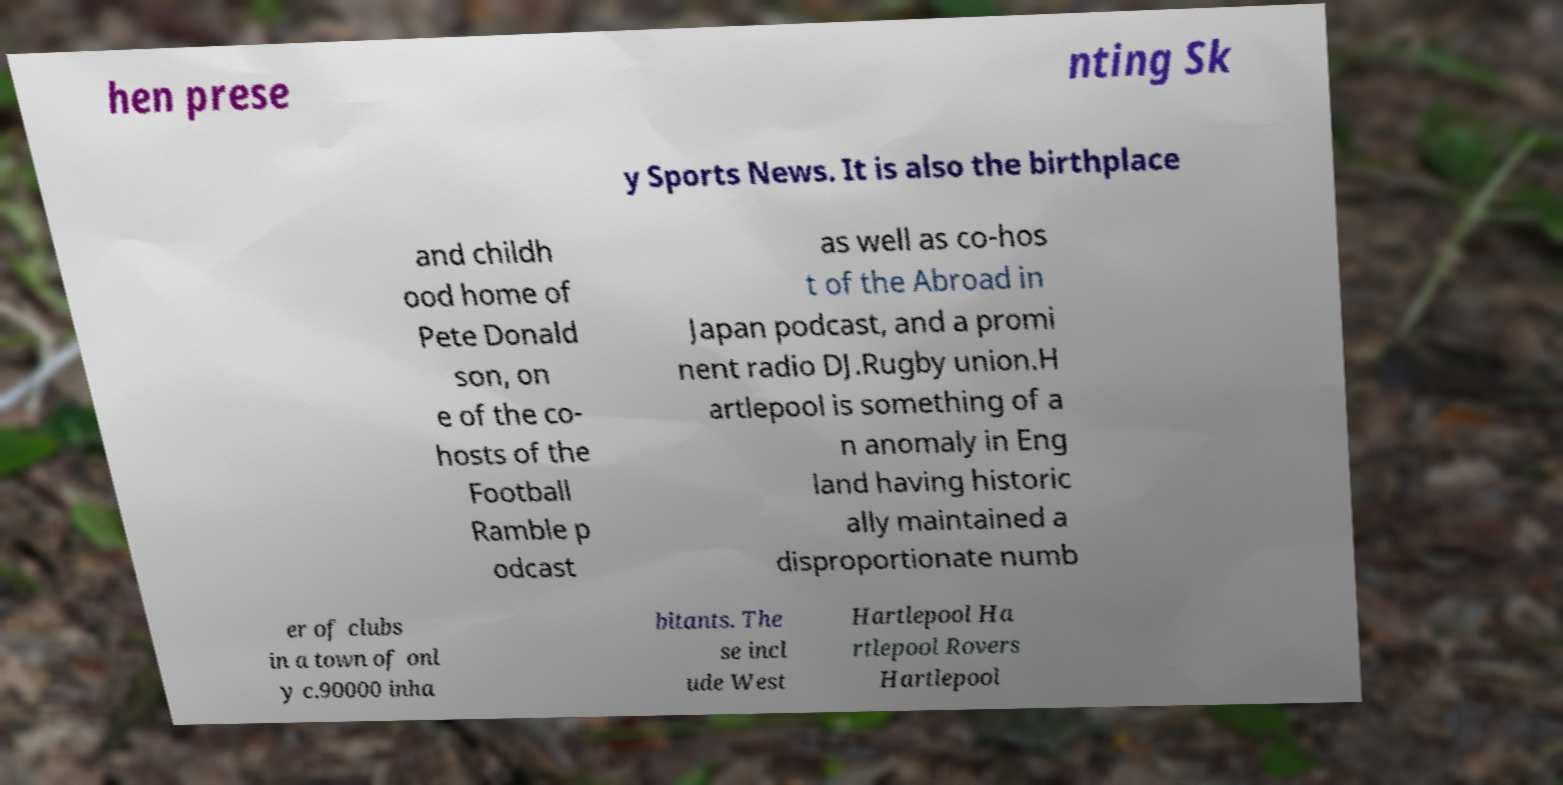Please identify and transcribe the text found in this image. hen prese nting Sk y Sports News. It is also the birthplace and childh ood home of Pete Donald son, on e of the co- hosts of the Football Ramble p odcast as well as co-hos t of the Abroad in Japan podcast, and a promi nent radio DJ.Rugby union.H artlepool is something of a n anomaly in Eng land having historic ally maintained a disproportionate numb er of clubs in a town of onl y c.90000 inha bitants. The se incl ude West Hartlepool Ha rtlepool Rovers Hartlepool 